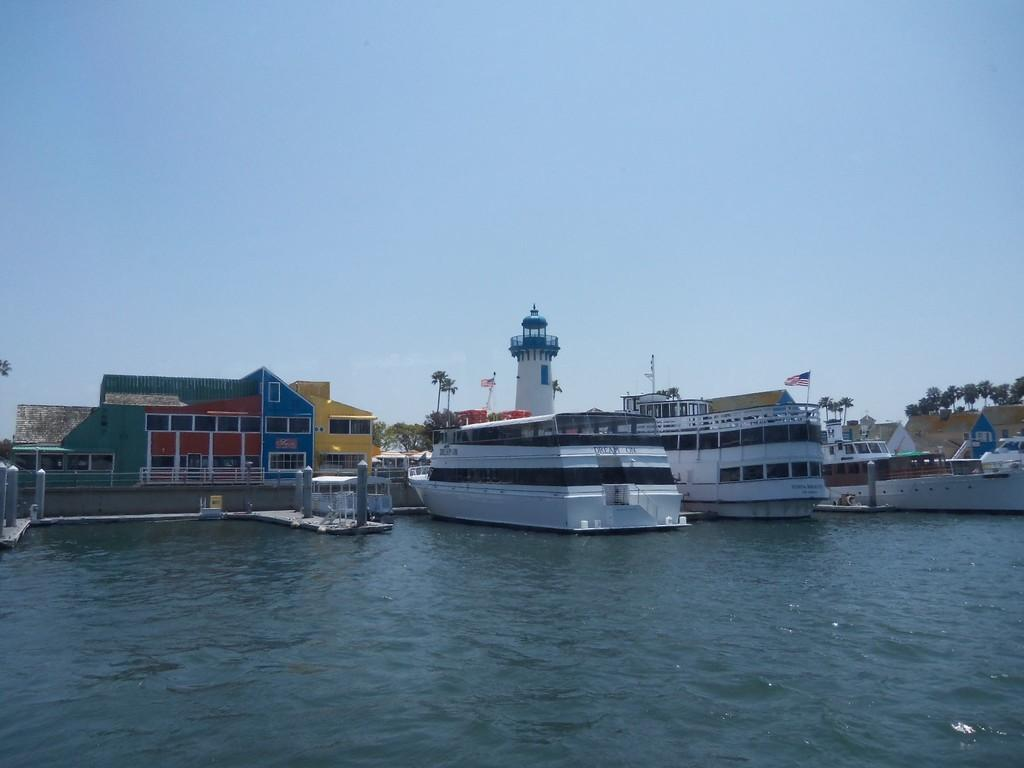What type of vehicles can be seen in the image? There are boats in the image. What type of structures are present in the image? There are houses in the image. What type of natural vegetation is visible in the image? There are trees in the image. What type of symbol is present in the image? There is a flag in the image. What type of natural phenomena can be seen in the image? There are waves in the image. What type of environment is visible in the image? There is water and sky visible in the image. What type of animal can be seen baiting the butter in the image? There is no animal or butter present in the image. What type of creature is shown interacting with the butter in the image? There is no creature shown interacting with butter in the image; only boats, houses, trees, a flag, waves, water, and sky are present. 